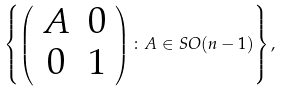<formula> <loc_0><loc_0><loc_500><loc_500>\left \{ \left ( \begin{array} { c c } A & 0 \\ 0 & 1 \end{array} \right ) \colon A \in S O ( n - 1 ) \right \} ,</formula> 